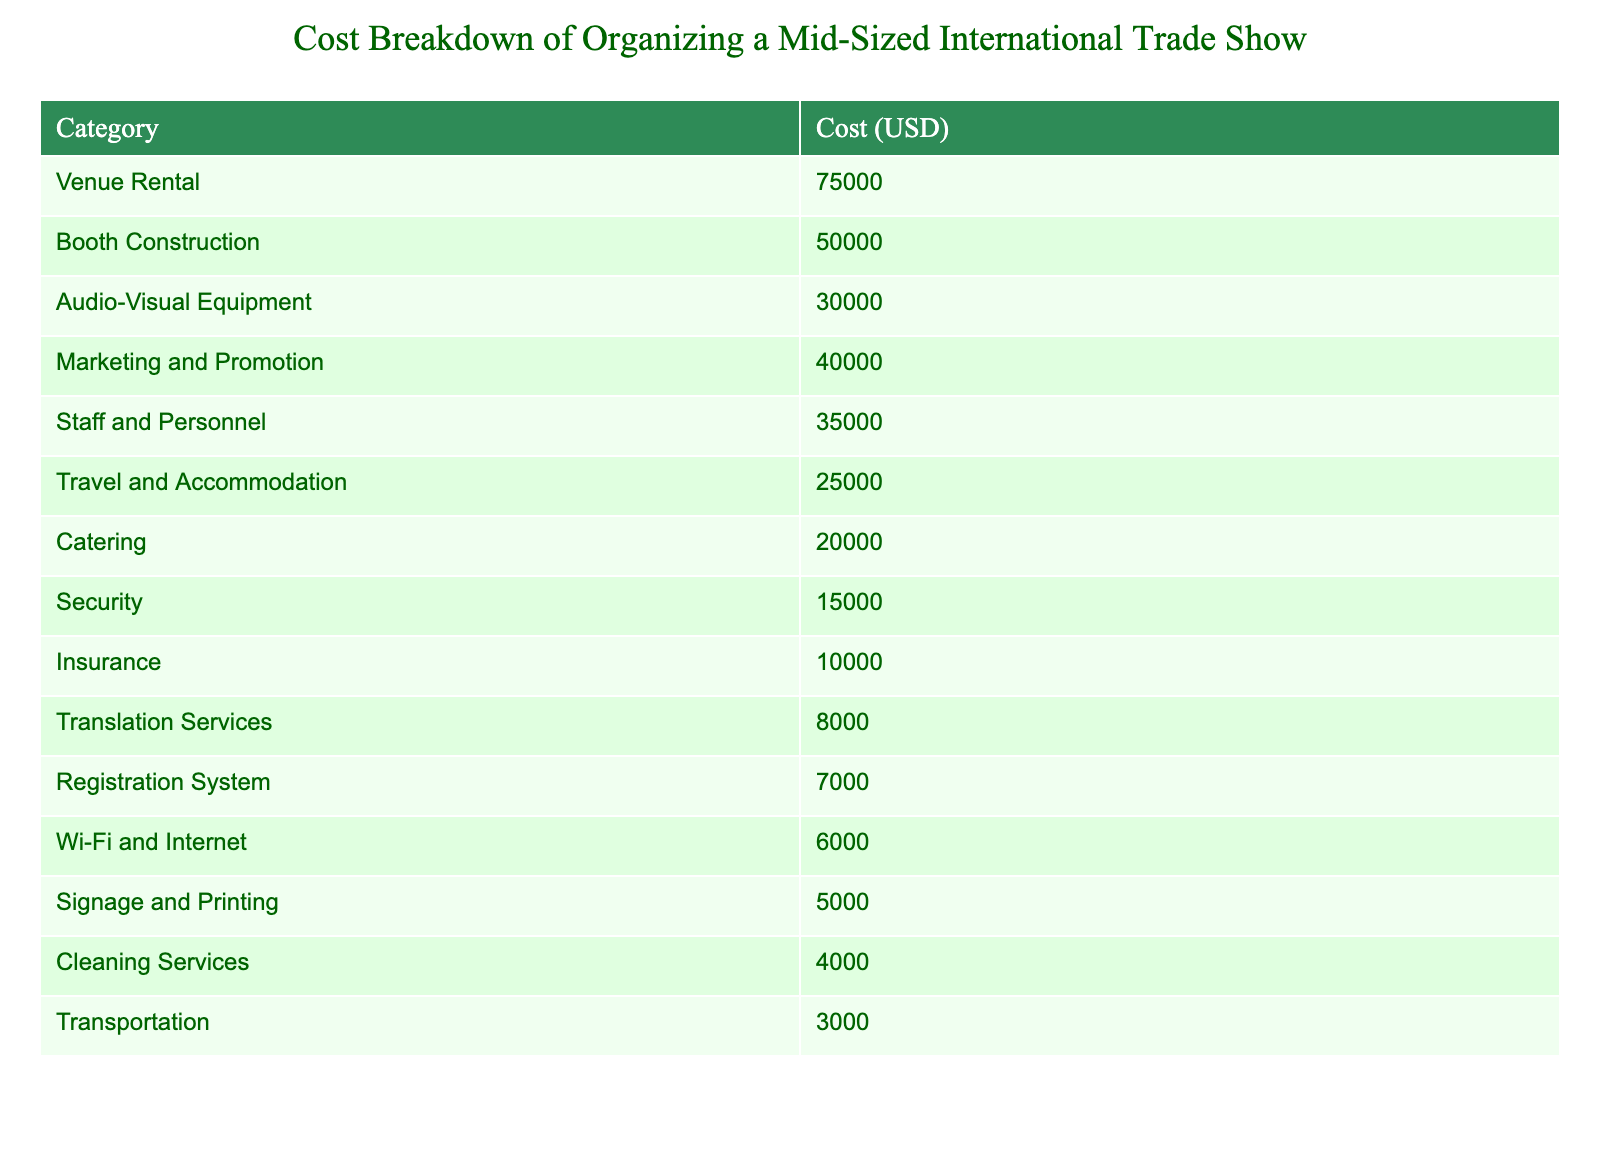What is the cost for booth construction? The table shows that the cost for booth construction is explicitly stated under the "Cost (USD)" column corresponding to "Booth Construction." It is straightforward to identify this value.
Answer: 50000 What is the total cost of catering and security combined? To find this, we need to sum the values of Catering (20000) and Security (15000). The calculation is 20000 + 15000 = 35000.
Answer: 35000 Is the cost for audio-visual equipment higher than the cost for travel and accommodation? From the table, the cost for audio-visual equipment is 30000 and the cost for travel and accommodation is 25000. Since 30000 is greater than 25000, the answer is yes.
Answer: Yes What is the average cost of the three highest expenses: venue rental, booth construction, and marketing and promotion? First, we identify the three highest costs: Venue Rental (75000), Booth Construction (50000), and Marketing and Promotion (40000). We add these values: 75000 + 50000 + 40000 = 165000. Since there are three expenses, we calculate the average: 165000 / 3 = 55000.
Answer: 55000 What is the total cost of all the listed services? We need to add all the values from the "Cost (USD)" column. The total is calculated as follows: 75000 + 50000 + 30000 + 40000 + 35000 + 25000 + 20000 + 15000 + 10000 + 8000 + 7000 + 6000 + 5000 + 4000 + 3000 = 319000.
Answer: 319000 Is the cost of marketing and promotion equal to the sum of the costs for signage and printing plus cleaning services? The cost for marketing and promotion is 40000. The combined costs for signage and printing (5000) and cleaning services (4000) are 5000 + 4000 = 9000. Since 40000 is not equal to 9000, the answer is no.
Answer: No What is the difference in cost between insurance and translation services? The cost for Insurance is 10000, and for Translation Services, it is 8000. The difference is calculated as 10000 - 8000 = 2000.
Answer: 2000 What percentage of the total cost does staff and personnel account for? First, we know the total cost is 319000 (calculated previously). The cost for Staff and Personnel is 35000. To find the percentage, we use the formula: (35000 / 319000) * 100 = 10.96%.
Answer: 10.96% What is the minimum cost among all the listed categories? We need to identify the minimum value from the "Cost (USD)" column. The lowest value appears next to Transportation, which is 3000.
Answer: 3000 